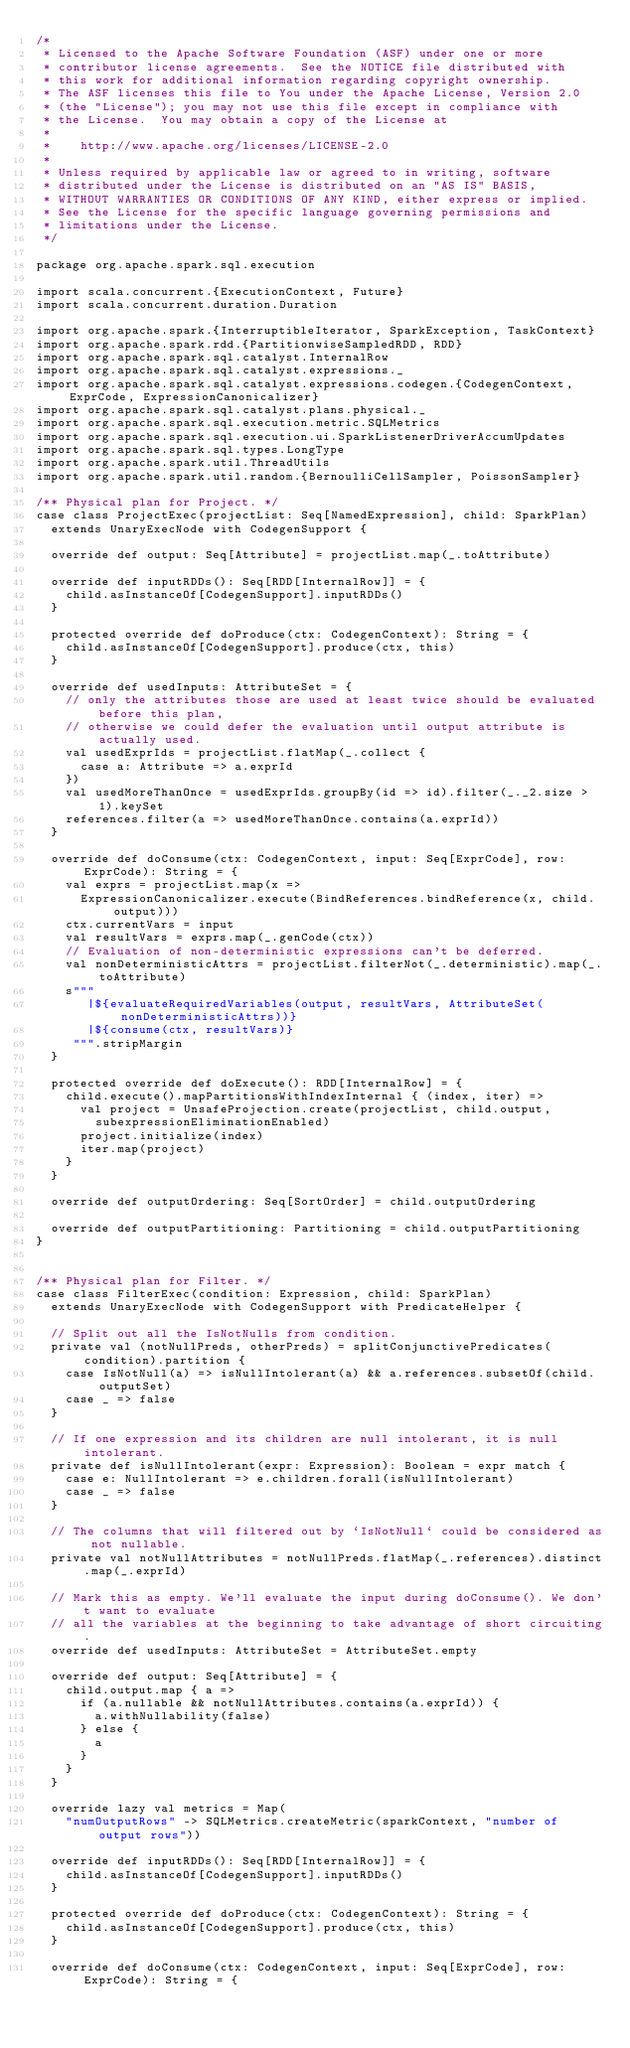Convert code to text. <code><loc_0><loc_0><loc_500><loc_500><_Scala_>/*
 * Licensed to the Apache Software Foundation (ASF) under one or more
 * contributor license agreements.  See the NOTICE file distributed with
 * this work for additional information regarding copyright ownership.
 * The ASF licenses this file to You under the Apache License, Version 2.0
 * (the "License"); you may not use this file except in compliance with
 * the License.  You may obtain a copy of the License at
 *
 *    http://www.apache.org/licenses/LICENSE-2.0
 *
 * Unless required by applicable law or agreed to in writing, software
 * distributed under the License is distributed on an "AS IS" BASIS,
 * WITHOUT WARRANTIES OR CONDITIONS OF ANY KIND, either express or implied.
 * See the License for the specific language governing permissions and
 * limitations under the License.
 */

package org.apache.spark.sql.execution

import scala.concurrent.{ExecutionContext, Future}
import scala.concurrent.duration.Duration

import org.apache.spark.{InterruptibleIterator, SparkException, TaskContext}
import org.apache.spark.rdd.{PartitionwiseSampledRDD, RDD}
import org.apache.spark.sql.catalyst.InternalRow
import org.apache.spark.sql.catalyst.expressions._
import org.apache.spark.sql.catalyst.expressions.codegen.{CodegenContext, ExprCode, ExpressionCanonicalizer}
import org.apache.spark.sql.catalyst.plans.physical._
import org.apache.spark.sql.execution.metric.SQLMetrics
import org.apache.spark.sql.execution.ui.SparkListenerDriverAccumUpdates
import org.apache.spark.sql.types.LongType
import org.apache.spark.util.ThreadUtils
import org.apache.spark.util.random.{BernoulliCellSampler, PoissonSampler}

/** Physical plan for Project. */
case class ProjectExec(projectList: Seq[NamedExpression], child: SparkPlan)
  extends UnaryExecNode with CodegenSupport {

  override def output: Seq[Attribute] = projectList.map(_.toAttribute)

  override def inputRDDs(): Seq[RDD[InternalRow]] = {
    child.asInstanceOf[CodegenSupport].inputRDDs()
  }

  protected override def doProduce(ctx: CodegenContext): String = {
    child.asInstanceOf[CodegenSupport].produce(ctx, this)
  }

  override def usedInputs: AttributeSet = {
    // only the attributes those are used at least twice should be evaluated before this plan,
    // otherwise we could defer the evaluation until output attribute is actually used.
    val usedExprIds = projectList.flatMap(_.collect {
      case a: Attribute => a.exprId
    })
    val usedMoreThanOnce = usedExprIds.groupBy(id => id).filter(_._2.size > 1).keySet
    references.filter(a => usedMoreThanOnce.contains(a.exprId))
  }

  override def doConsume(ctx: CodegenContext, input: Seq[ExprCode], row: ExprCode): String = {
    val exprs = projectList.map(x =>
      ExpressionCanonicalizer.execute(BindReferences.bindReference(x, child.output)))
    ctx.currentVars = input
    val resultVars = exprs.map(_.genCode(ctx))
    // Evaluation of non-deterministic expressions can't be deferred.
    val nonDeterministicAttrs = projectList.filterNot(_.deterministic).map(_.toAttribute)
    s"""
       |${evaluateRequiredVariables(output, resultVars, AttributeSet(nonDeterministicAttrs))}
       |${consume(ctx, resultVars)}
     """.stripMargin
  }

  protected override def doExecute(): RDD[InternalRow] = {
    child.execute().mapPartitionsWithIndexInternal { (index, iter) =>
      val project = UnsafeProjection.create(projectList, child.output,
        subexpressionEliminationEnabled)
      project.initialize(index)
      iter.map(project)
    }
  }

  override def outputOrdering: Seq[SortOrder] = child.outputOrdering

  override def outputPartitioning: Partitioning = child.outputPartitioning
}


/** Physical plan for Filter. */
case class FilterExec(condition: Expression, child: SparkPlan)
  extends UnaryExecNode with CodegenSupport with PredicateHelper {

  // Split out all the IsNotNulls from condition.
  private val (notNullPreds, otherPreds) = splitConjunctivePredicates(condition).partition {
    case IsNotNull(a) => isNullIntolerant(a) && a.references.subsetOf(child.outputSet)
    case _ => false
  }

  // If one expression and its children are null intolerant, it is null intolerant.
  private def isNullIntolerant(expr: Expression): Boolean = expr match {
    case e: NullIntolerant => e.children.forall(isNullIntolerant)
    case _ => false
  }

  // The columns that will filtered out by `IsNotNull` could be considered as not nullable.
  private val notNullAttributes = notNullPreds.flatMap(_.references).distinct.map(_.exprId)

  // Mark this as empty. We'll evaluate the input during doConsume(). We don't want to evaluate
  // all the variables at the beginning to take advantage of short circuiting.
  override def usedInputs: AttributeSet = AttributeSet.empty

  override def output: Seq[Attribute] = {
    child.output.map { a =>
      if (a.nullable && notNullAttributes.contains(a.exprId)) {
        a.withNullability(false)
      } else {
        a
      }
    }
  }

  override lazy val metrics = Map(
    "numOutputRows" -> SQLMetrics.createMetric(sparkContext, "number of output rows"))

  override def inputRDDs(): Seq[RDD[InternalRow]] = {
    child.asInstanceOf[CodegenSupport].inputRDDs()
  }

  protected override def doProduce(ctx: CodegenContext): String = {
    child.asInstanceOf[CodegenSupport].produce(ctx, this)
  }

  override def doConsume(ctx: CodegenContext, input: Seq[ExprCode], row: ExprCode): String = {</code> 